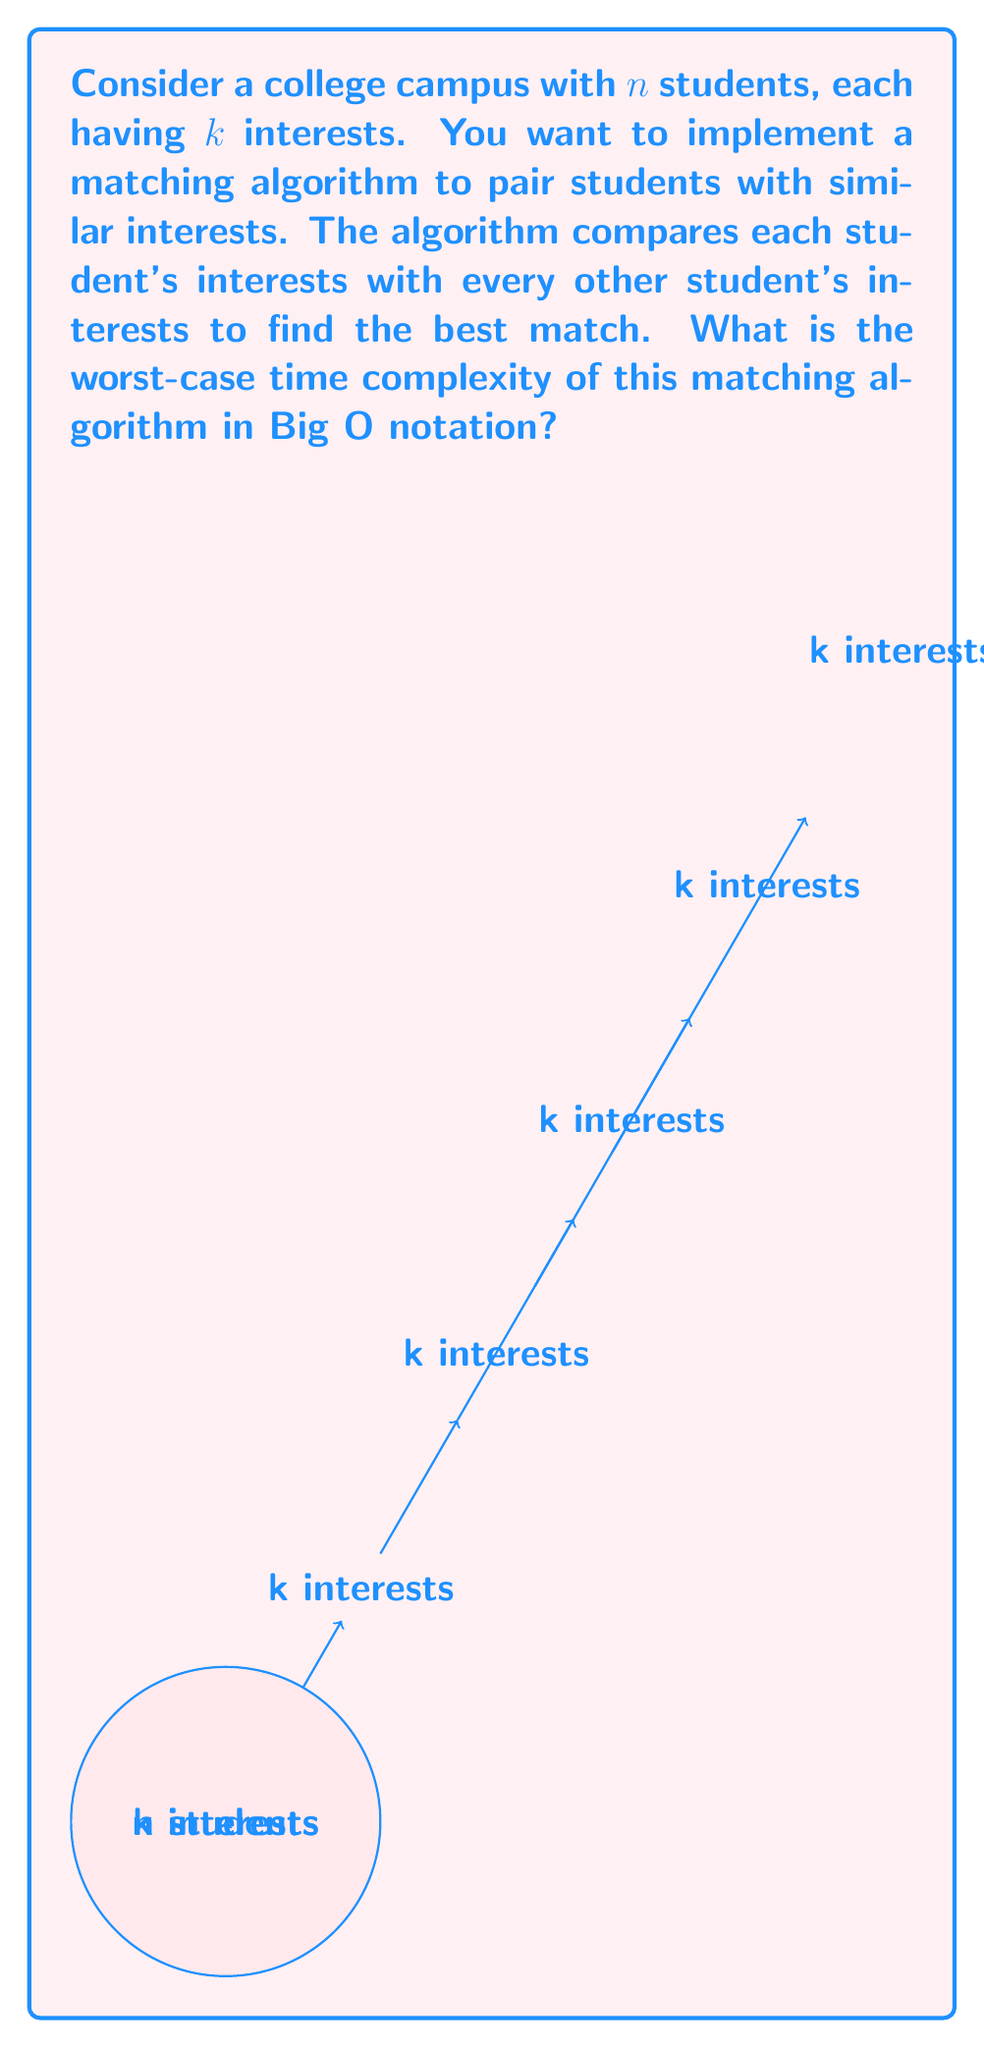Can you solve this math problem? To solve this problem, let's break it down step-by-step:

1) First, we need to compare each student with every other student. This results in $\binom{n}{2} = \frac{n(n-1)}{2}$ comparisons.

2) For each comparison, we need to check all $k$ interests of both students against each other. This requires $k^2$ operations for each pair of students.

3) Therefore, the total number of operations is:

   $$\frac{n(n-1)}{2} \cdot k^2$$

4) Expanding this expression:

   $$\frac{n^2k^2 - nk^2}{2}$$

5) In Big O notation, we're interested in the dominant term as $n$ grows large. The dominant term here is $n^2k^2$.

6) We can drop the constant factor $\frac{1}{2}$, as it doesn't affect the asymptotic growth.

7) Therefore, the worst-case time complexity is $O(n^2k^2)$.
Answer: $O(n^2k^2)$ 